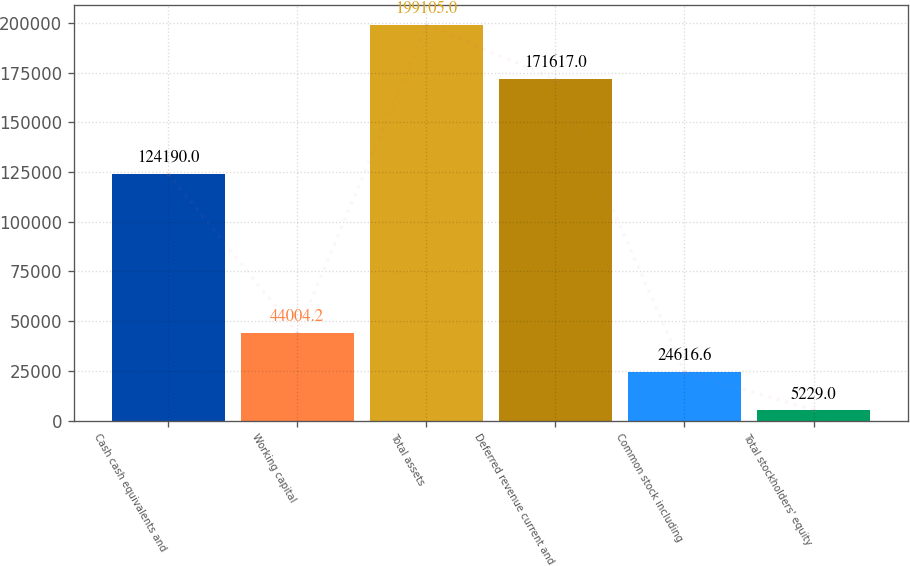<chart> <loc_0><loc_0><loc_500><loc_500><bar_chart><fcel>Cash cash equivalents and<fcel>Working capital<fcel>Total assets<fcel>Deferred revenue current and<fcel>Common stock including<fcel>Total stockholders' equity<nl><fcel>124190<fcel>44004.2<fcel>199105<fcel>171617<fcel>24616.6<fcel>5229<nl></chart> 